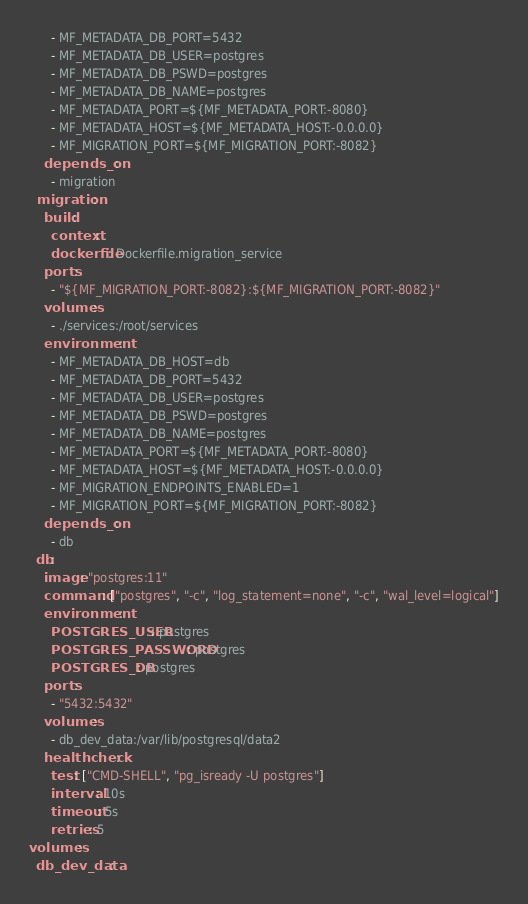<code> <loc_0><loc_0><loc_500><loc_500><_YAML_>      - MF_METADATA_DB_PORT=5432
      - MF_METADATA_DB_USER=postgres
      - MF_METADATA_DB_PSWD=postgres
      - MF_METADATA_DB_NAME=postgres
      - MF_METADATA_PORT=${MF_METADATA_PORT:-8080}
      - MF_METADATA_HOST=${MF_METADATA_HOST:-0.0.0.0}
      - MF_MIGRATION_PORT=${MF_MIGRATION_PORT:-8082}
    depends_on:
      - migration
  migration:
    build:
      context: .
      dockerfile: Dockerfile.migration_service
    ports:
      - "${MF_MIGRATION_PORT:-8082}:${MF_MIGRATION_PORT:-8082}"
    volumes:
      - ./services:/root/services
    environment:
      - MF_METADATA_DB_HOST=db
      - MF_METADATA_DB_PORT=5432
      - MF_METADATA_DB_USER=postgres
      - MF_METADATA_DB_PSWD=postgres
      - MF_METADATA_DB_NAME=postgres
      - MF_METADATA_PORT=${MF_METADATA_PORT:-8080}
      - MF_METADATA_HOST=${MF_METADATA_HOST:-0.0.0.0}
      - MF_MIGRATION_ENDPOINTS_ENABLED=1
      - MF_MIGRATION_PORT=${MF_MIGRATION_PORT:-8082}
    depends_on:
      - db
  db:
    image: "postgres:11"
    command: ["postgres", "-c", "log_statement=none", "-c", "wal_level=logical"]
    environment:
      POSTGRES_USER: postgres
      POSTGRES_PASSWORD: postgres
      POSTGRES_DB: postgres
    ports:
      - "5432:5432"
    volumes:
      - db_dev_data:/var/lib/postgresql/data2
    healthcheck:
      test: ["CMD-SHELL", "pg_isready -U postgres"]
      interval: 10s
      timeout: 5s
      retries: 5
volumes:
  db_dev_data:
</code> 